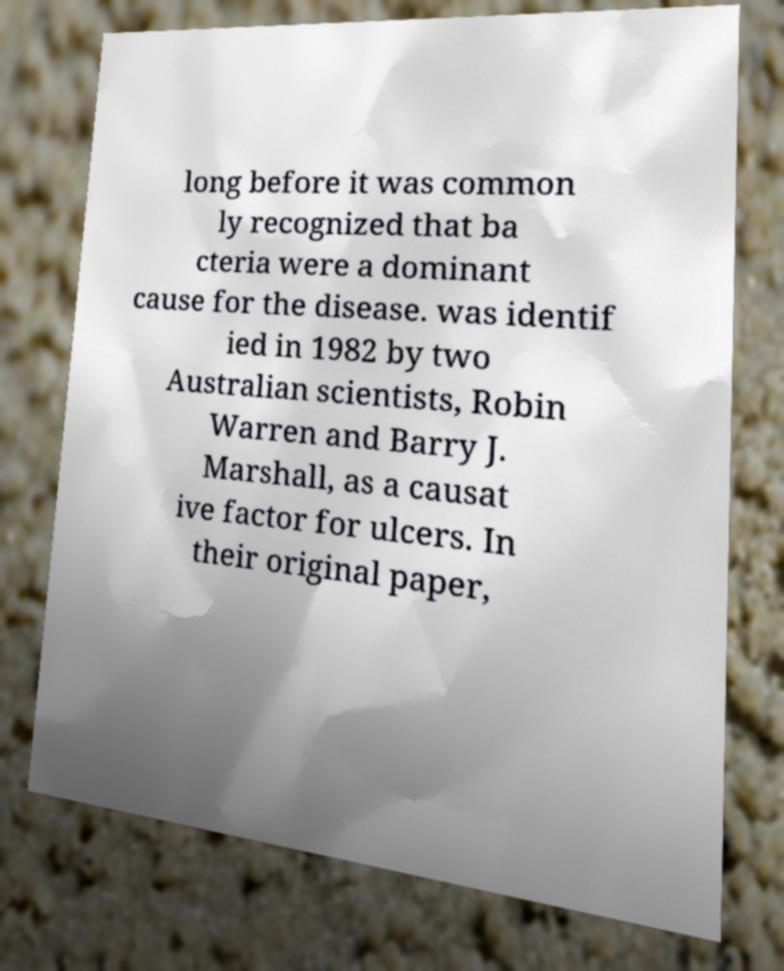There's text embedded in this image that I need extracted. Can you transcribe it verbatim? long before it was common ly recognized that ba cteria were a dominant cause for the disease. was identif ied in 1982 by two Australian scientists, Robin Warren and Barry J. Marshall, as a causat ive factor for ulcers. In their original paper, 